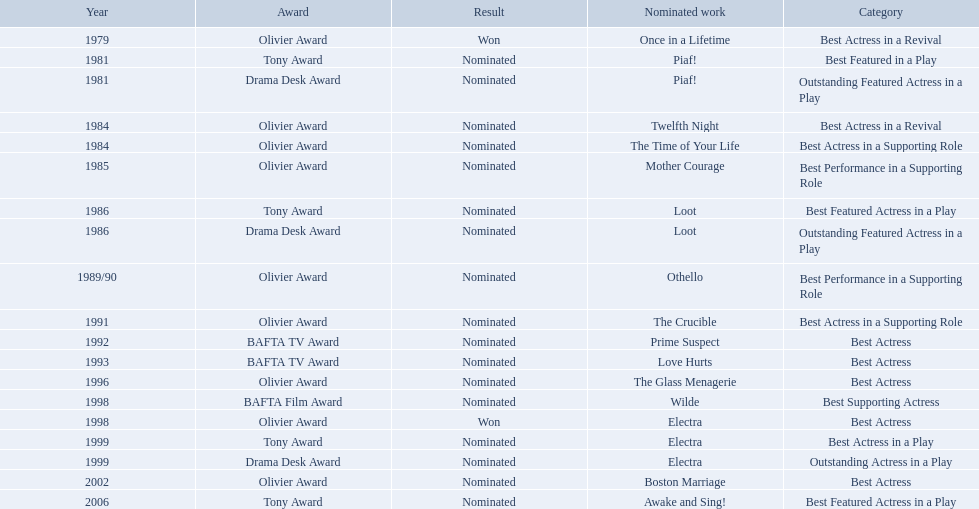What play was wanamaker nominated outstanding featured actress in a play? Piaf!. What year was wanamaker in once in a lifetime play? 1979. What play in 1984 was wanamaker nominated best actress? Twelfth Night. 